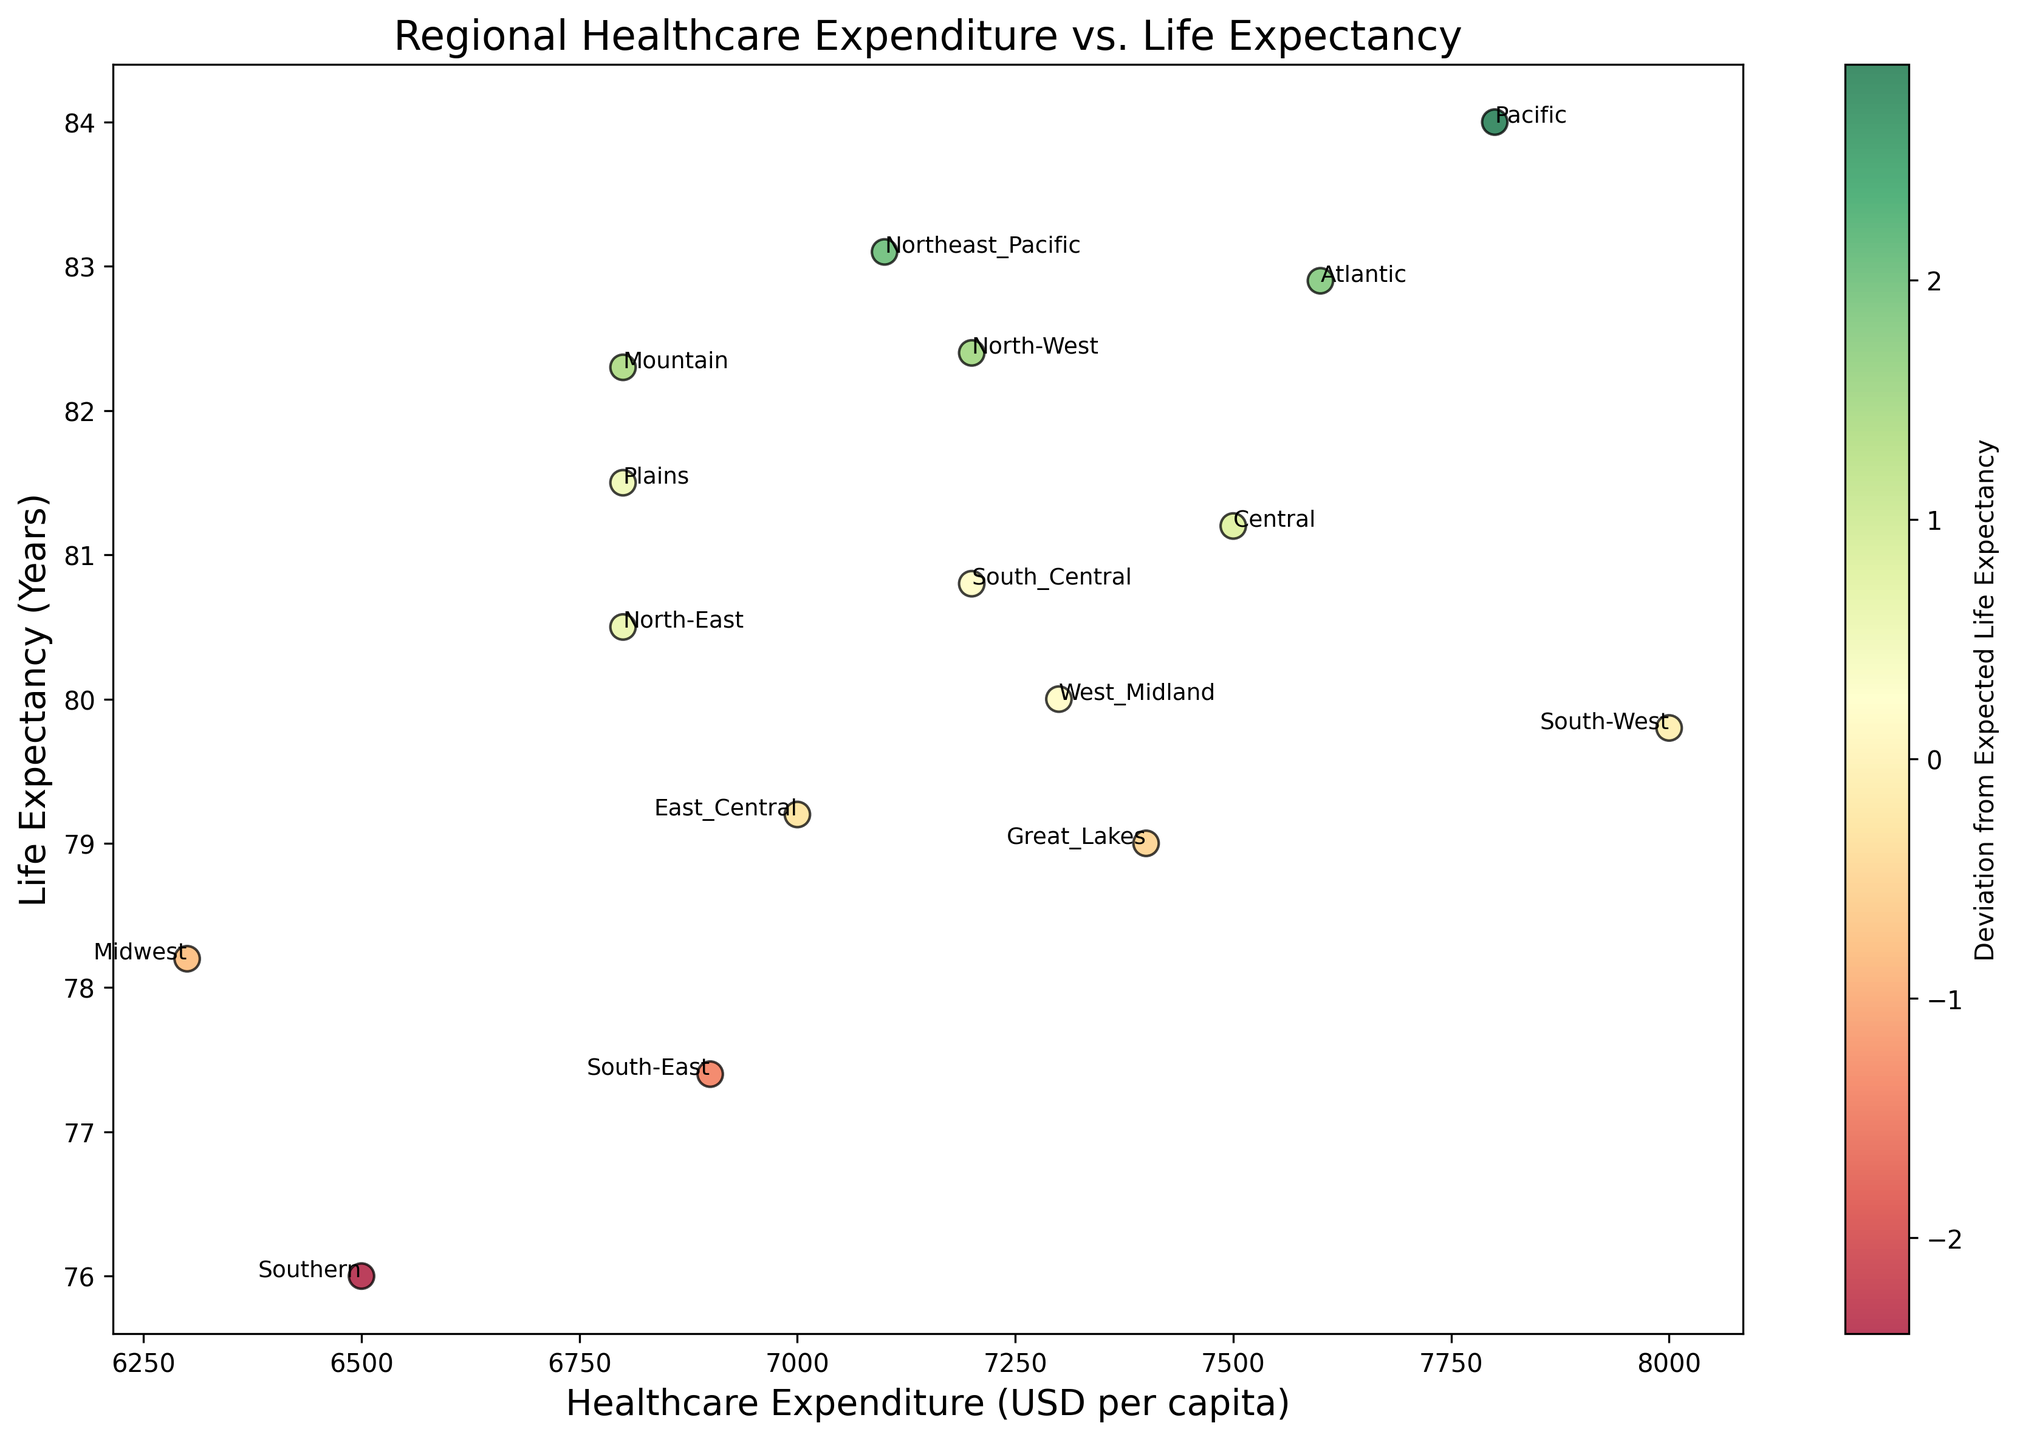Which region has the highest life expectancy, and what is its healthcare expenditure? The region with the highest life expectancy can be identified by finding the top data point on the y-axis corresponding to life expectancy. The Pacific region has the highest life expectancy of 84.0 years and a healthcare expenditure of 7800 USD per capita.
Answer: Pacific, 7800 USD Which regions have a negative deviation from expected life expectancy? Regions with a negative deviation can be found by identifying the points with colors representing negative deviations on the color bar and noting their corresponding regions. These regions are South-West, South-East, Midwest, Southern, Great Lakes, and East Central.
Answer: South-West, South-East, Midwest, Southern, Great Lakes, East Central Compare the healthcare expenditure of North-West and South-East. Which region spends more and by how much? North-West's healthcare expenditure is 7200 USD per capita, and South-East's expenditure is 6900 USD per capita. North-West spends more: 7200 - 6900 = 300 USD more per capita.
Answer: North-West, 300 USD What is the total healthcare expenditure of regions with a positive deviation from expected life expectancy? Sum the healthcare expenditures of the regions with a positive deviation. These regions are North-West (7200), North-East (6800), Central (7500), Northeast Pacific (7100), Mountain (6800), Atlantic (7600), and Pacific (7800). The total expenditure is 7200 + 6800 + 7500 + 7100 + 6800 + 7600 + 7800 = 50800 USD per capita.
Answer: 50800 USD per capita How does the deviation of Atlantic compare to that of Northeast Pacific? The deviation for Atlantic is 1.8, and for Northeast Pacific, it is 2.0. Northeast Pacific has a slightly higher deviation from expected life expectancy than Atlantic.
Answer: Northeast Pacific has higher deviation What is the average life expectancy of regions with a deviation greater than 1? Identify regions with a deviation greater than 1 (North-West, Northeast Pacific, Mountain, Atlantic, Pacific). Summing their life expectancies: 82.4 + 83.1 + 82.3 + 82.9 + 84.0 = 414.7. Average = 414.7 / 5 = 82.94 years.
Answer: 82.94 years Which region is closer to the expected life expectancy, West Midland or South-Central? The deviation for West Midland (0.2) and South-Central (0.2) are equal. Therefore, both regions are equally close to the expected life expectancy.
Answer: Both regions are equally close 